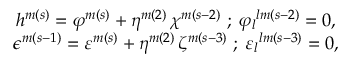<formula> <loc_0><loc_0><loc_500><loc_500>\begin{array} { c } { { h ^ { m ( s ) } = \varphi ^ { m ( s ) } + \eta ^ { m ( 2 ) } \, \chi ^ { m ( s - 2 ) } \, ; \, { \varphi _ { l } } ^ { l m ( s - 2 ) } = 0 , } } \\ { { \epsilon ^ { m ( s - 1 ) } = \varepsilon ^ { m ( s ) } + \eta ^ { m ( 2 ) } \, \zeta ^ { m ( s - 3 ) } \, ; \, { \varepsilon _ { l } } ^ { l m ( s - 3 ) } = 0 , } } \end{array}</formula> 